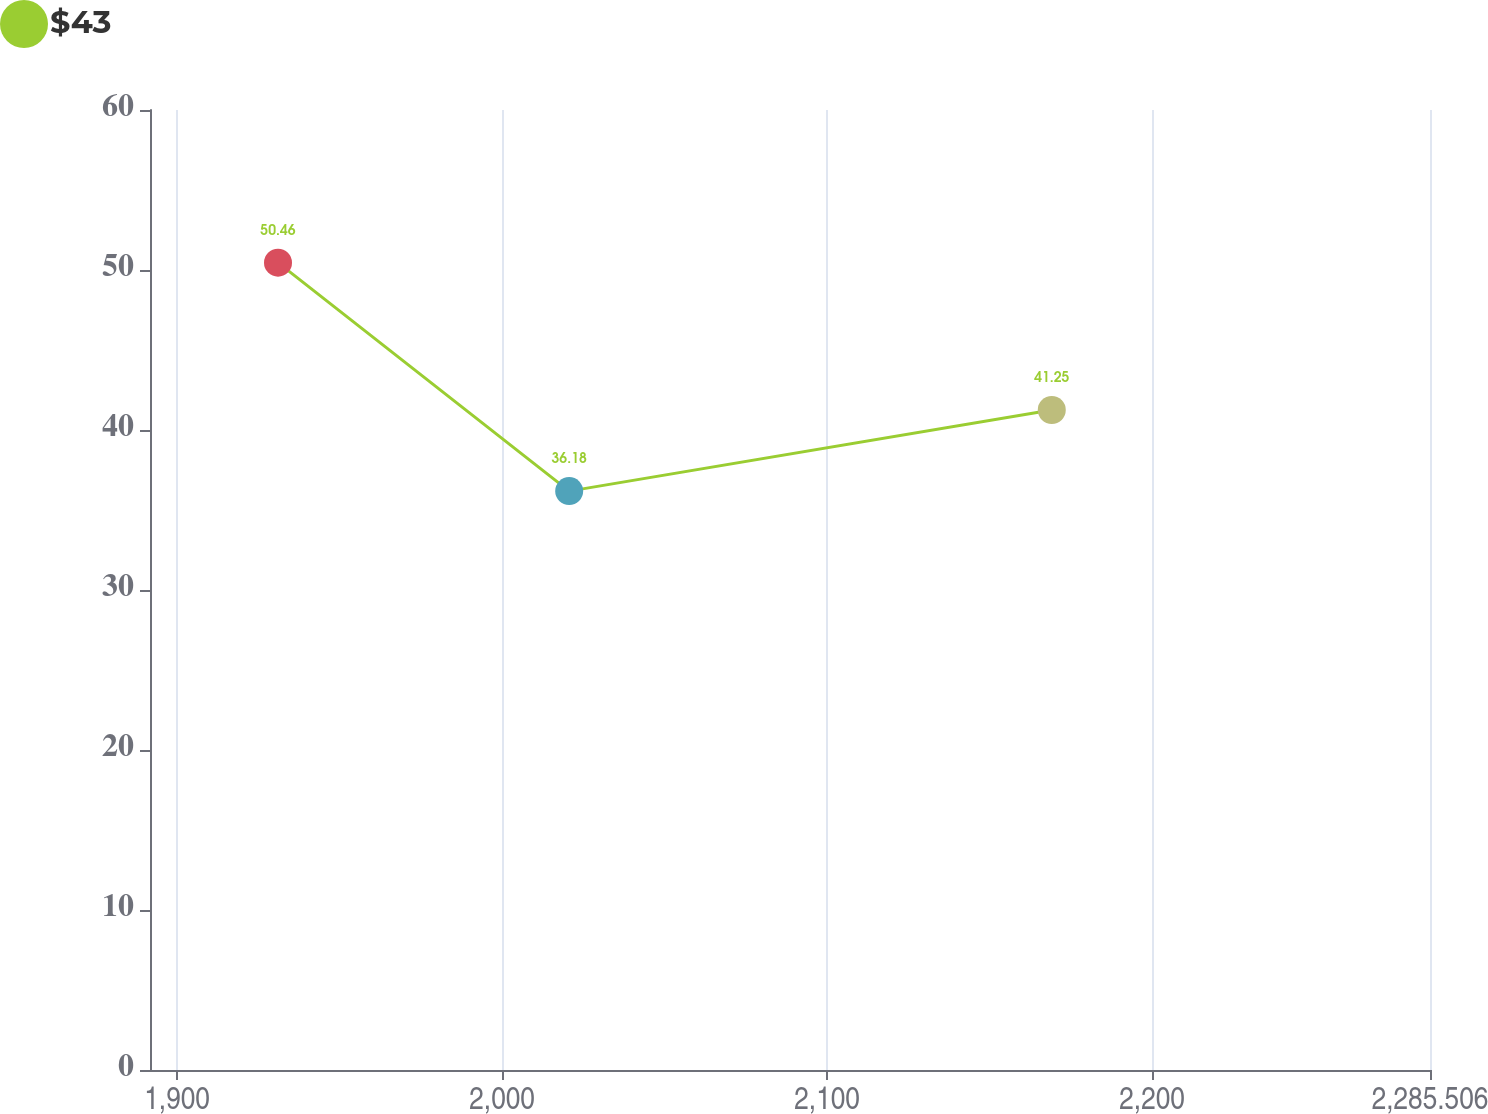<chart> <loc_0><loc_0><loc_500><loc_500><line_chart><ecel><fcel>$43<nl><fcel>1931.05<fcel>50.46<nl><fcel>2020.64<fcel>36.18<nl><fcel>2169.13<fcel>41.25<nl><fcel>2324.89<fcel>42.68<nl></chart> 